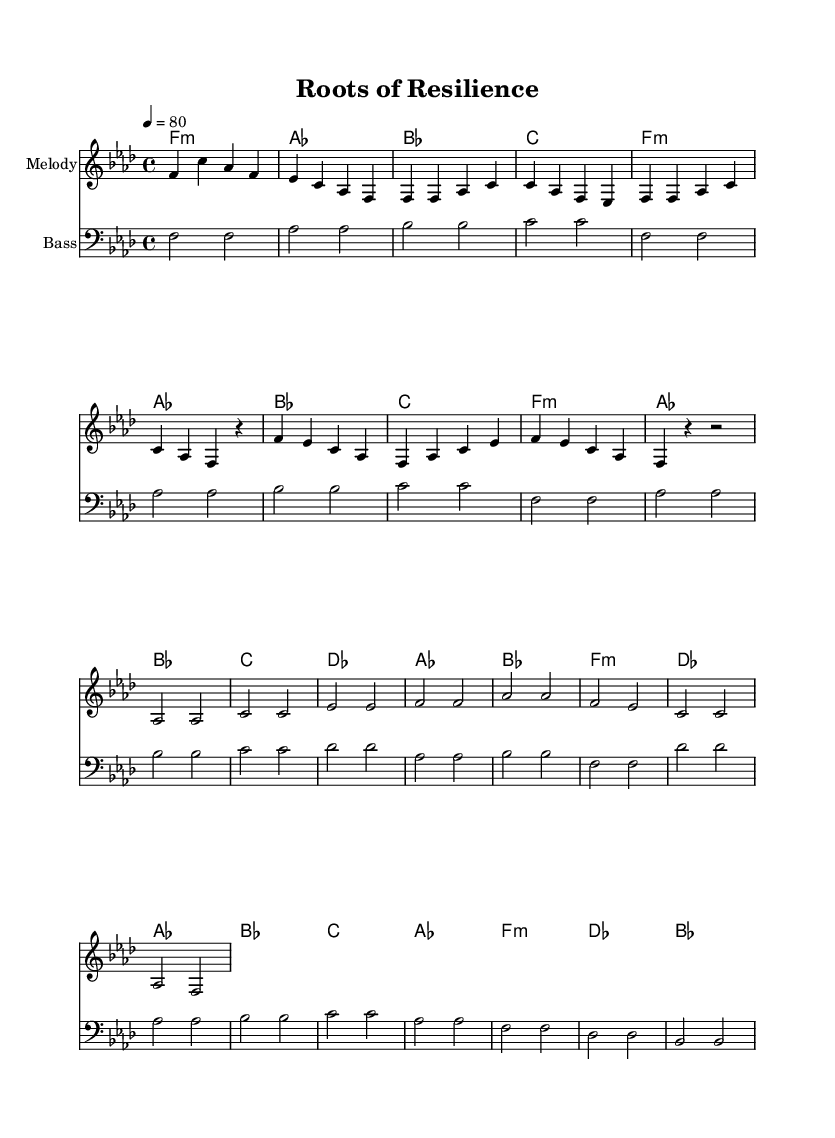What is the key signature of this music? The key signature is noted at the beginning of the sheet music. In this case, it shows that there are four flats, which correlates to the key of F minor.
Answer: F minor What is the time signature of this music? The time signature is found at the beginning of the music sheet. It is indicated as 4/4, which means there are four beats in each measure and the quarter note gets one beat.
Answer: 4/4 What is the tempo marking for this piece? The tempo marking is usually indicated in the global section at the beginning of the music. Here, it states "4 = 80," meaning there are 80 beats per minute.
Answer: 80 How many measures are there in the chorus section? To find the number of measures, count the measures in the chorus section specifically noted in the structure. The chorus is shown to have four measures.
Answer: 4 What is the primary theme explored in the lyrics? The lyrics focus on historical and cultural themes, particularly the journey from Africa to America, emphasizing resilience and heritage. Taking cues from the words displayed, the central theme revolves around continuity and ancestral wisdom.
Answer: Resilience and heritage What type of harmony is prevalent in the song's structure? The harmony sections are denoted under the chord names. The chords used point to a common jazz and R&B technique of layering, primarily using minor and major chords, indicative of a rich harmonic tradition in R&B.
Answer: Minor and major chords What emotion does the bridge evoke based on the musical structure? The bridge typically serves as the contrasting section, shifting slightly in harmonic and melodic development to evoke different emotions. Here, the bridge uses lighter and more uplifting chords, suggesting hope and connection to heritage.
Answer: Hope and connection 